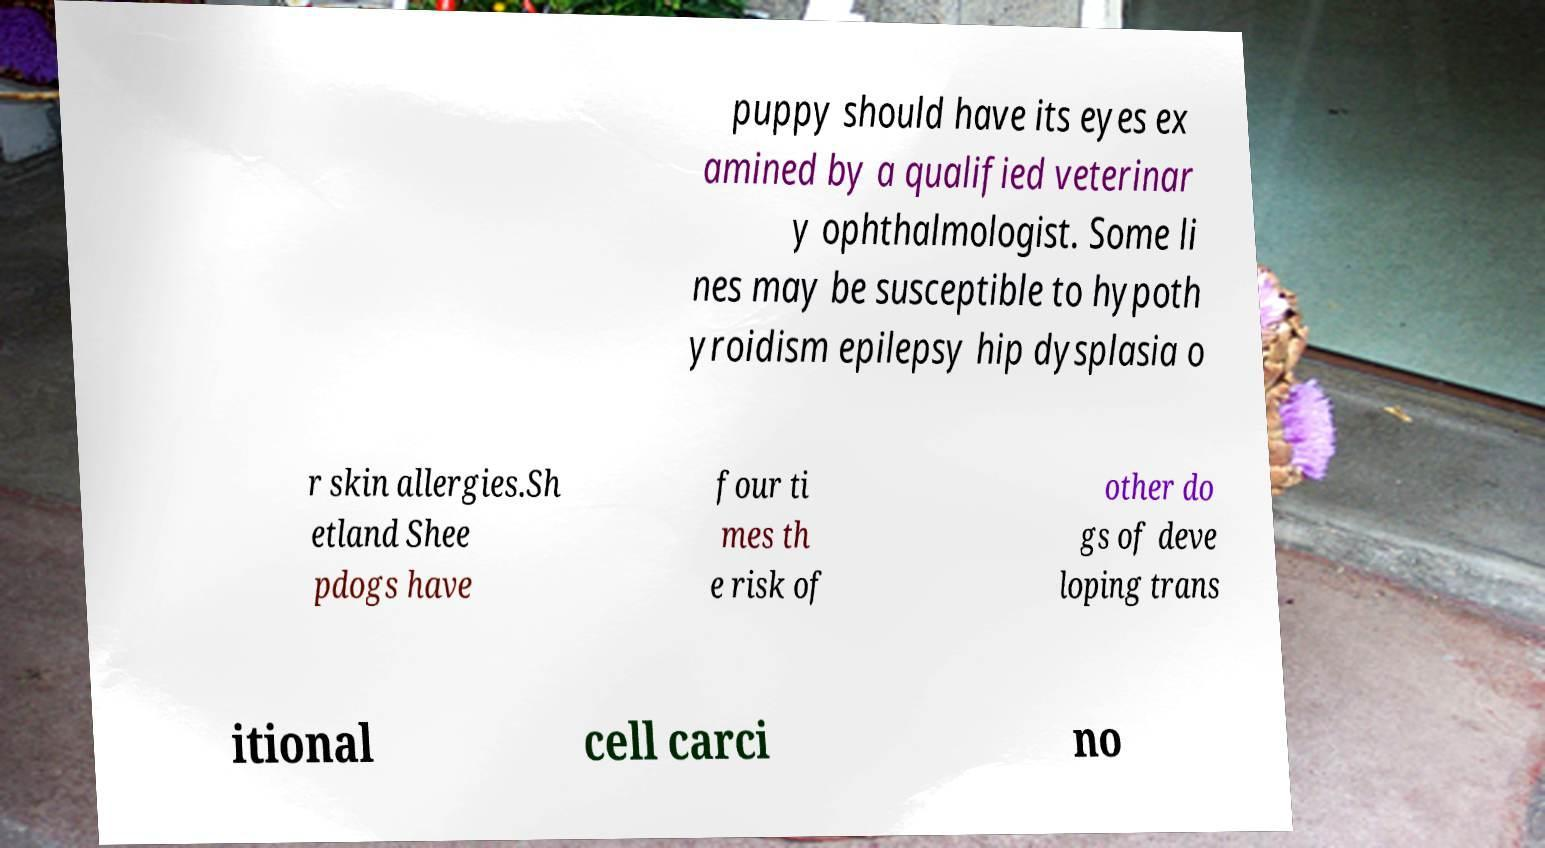Could you extract and type out the text from this image? puppy should have its eyes ex amined by a qualified veterinar y ophthalmologist. Some li nes may be susceptible to hypoth yroidism epilepsy hip dysplasia o r skin allergies.Sh etland Shee pdogs have four ti mes th e risk of other do gs of deve loping trans itional cell carci no 